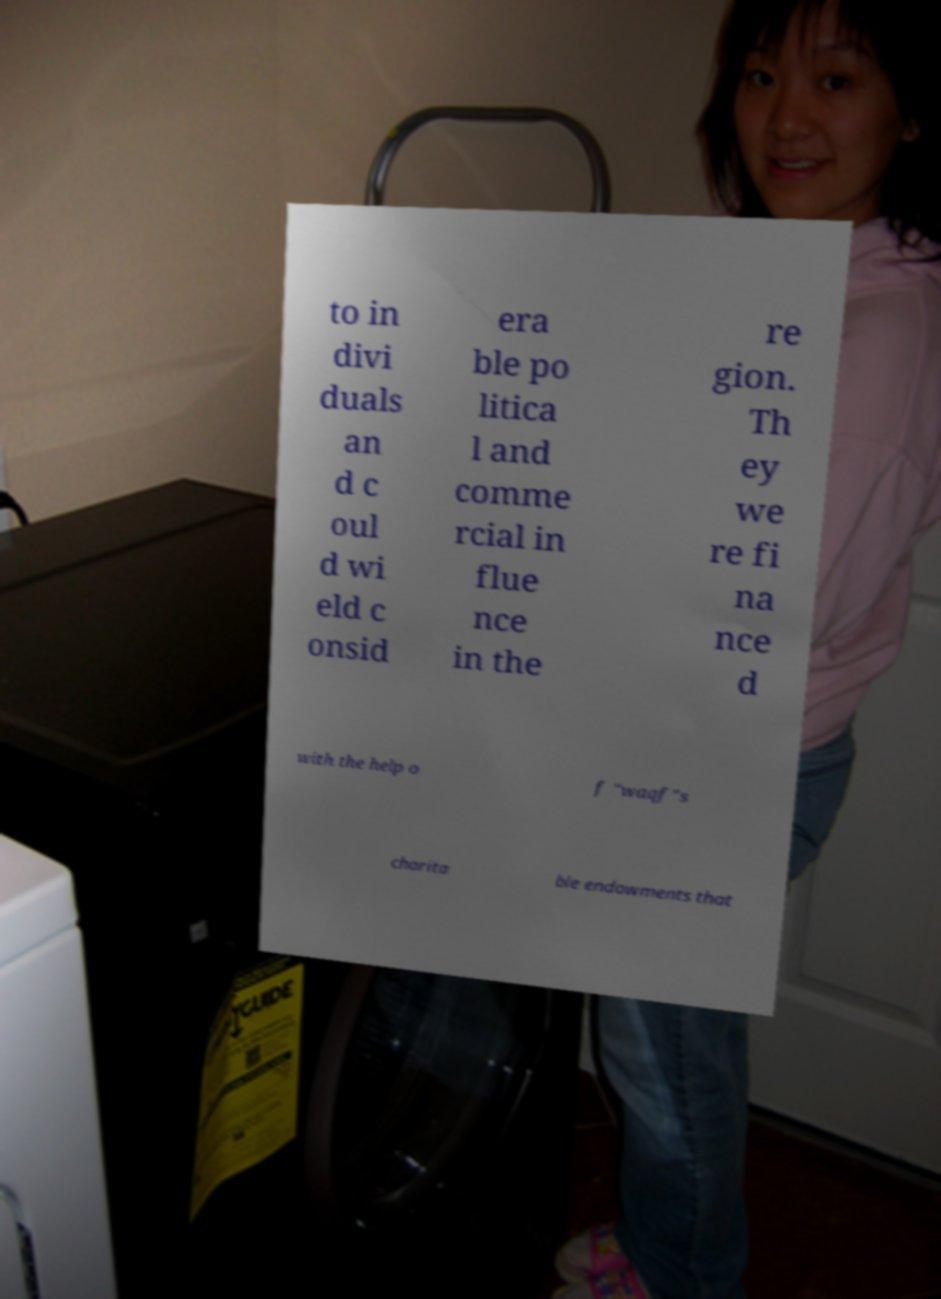There's text embedded in this image that I need extracted. Can you transcribe it verbatim? to in divi duals an d c oul d wi eld c onsid era ble po litica l and comme rcial in flue nce in the re gion. Th ey we re fi na nce d with the help o f "waqf"s charita ble endowments that 